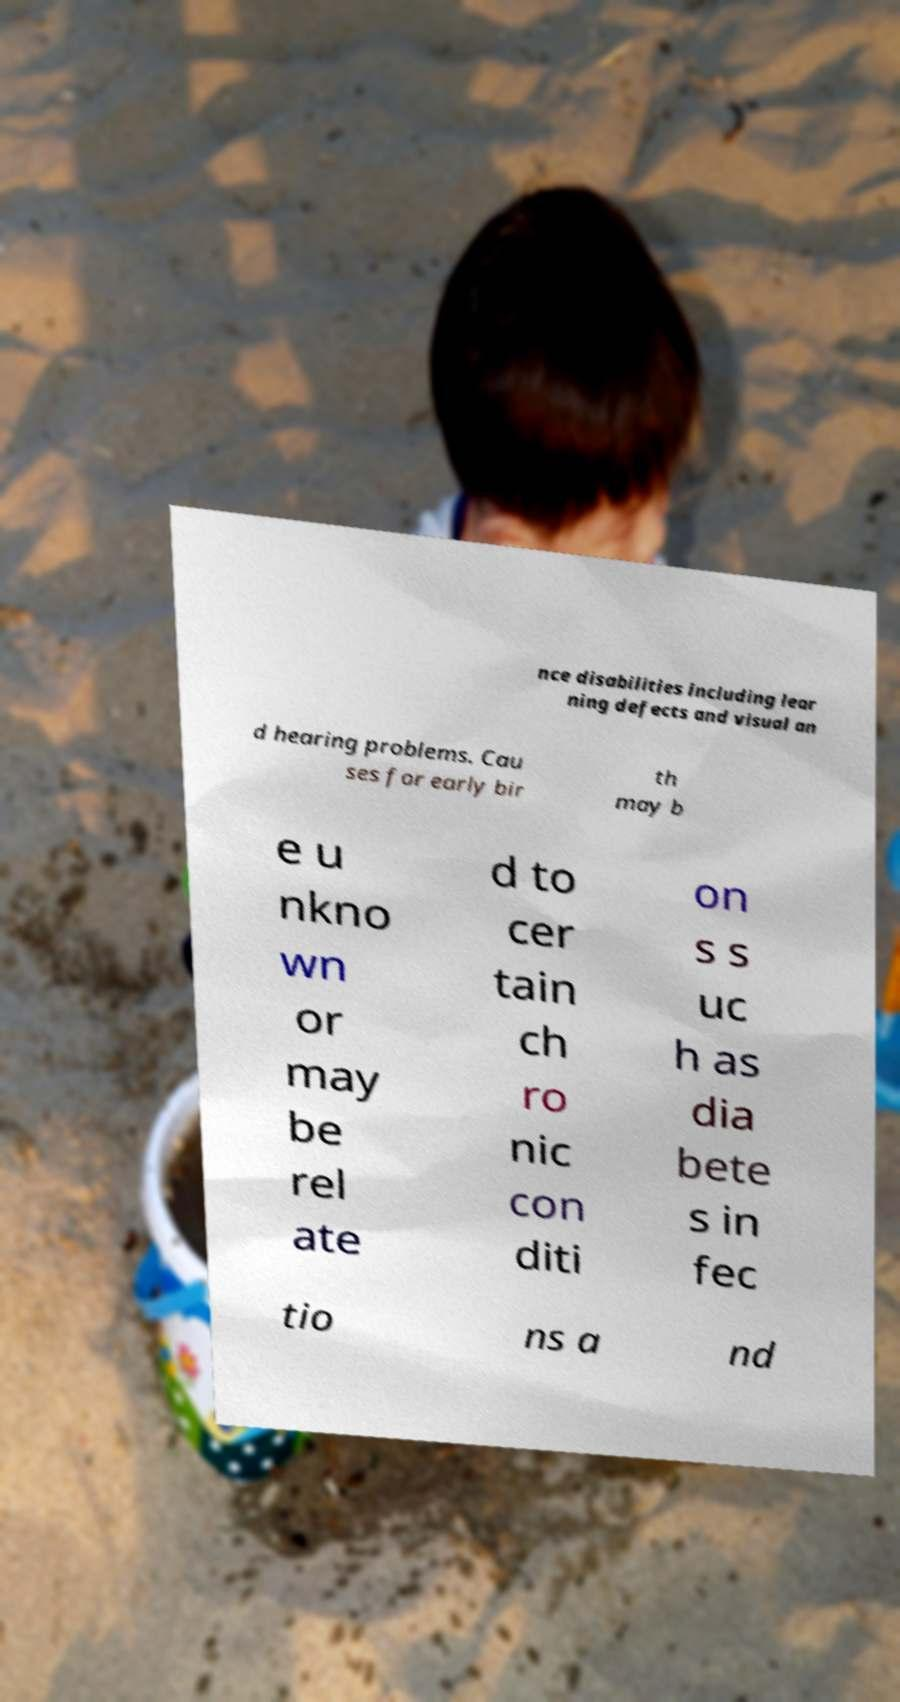For documentation purposes, I need the text within this image transcribed. Could you provide that? nce disabilities including lear ning defects and visual an d hearing problems. Cau ses for early bir th may b e u nkno wn or may be rel ate d to cer tain ch ro nic con diti on s s uc h as dia bete s in fec tio ns a nd 